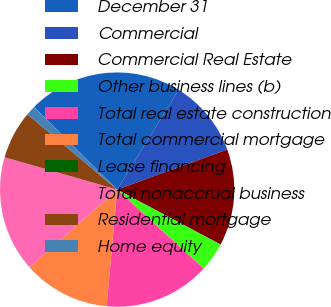<chart> <loc_0><loc_0><loc_500><loc_500><pie_chart><fcel>December 31<fcel>Commercial<fcel>Commercial Real Estate<fcel>Other business lines (b)<fcel>Total real estate construction<fcel>Total commercial mortgage<fcel>Lease financing<fcel>Total nonaccrual business<fcel>Residential mortgage<fcel>Home equity<nl><fcel>21.33%<fcel>10.67%<fcel>13.33%<fcel>4.0%<fcel>14.66%<fcel>12.0%<fcel>0.01%<fcel>16.0%<fcel>6.67%<fcel>1.34%<nl></chart> 